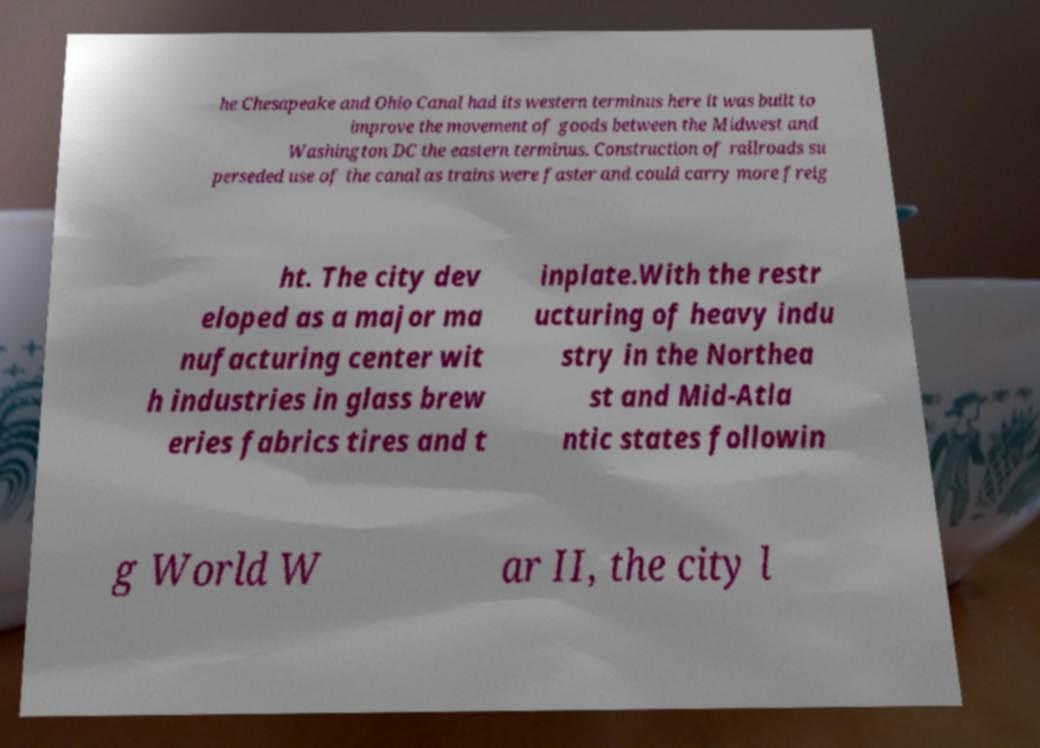Could you assist in decoding the text presented in this image and type it out clearly? he Chesapeake and Ohio Canal had its western terminus here it was built to improve the movement of goods between the Midwest and Washington DC the eastern terminus. Construction of railroads su perseded use of the canal as trains were faster and could carry more freig ht. The city dev eloped as a major ma nufacturing center wit h industries in glass brew eries fabrics tires and t inplate.With the restr ucturing of heavy indu stry in the Northea st and Mid-Atla ntic states followin g World W ar II, the city l 